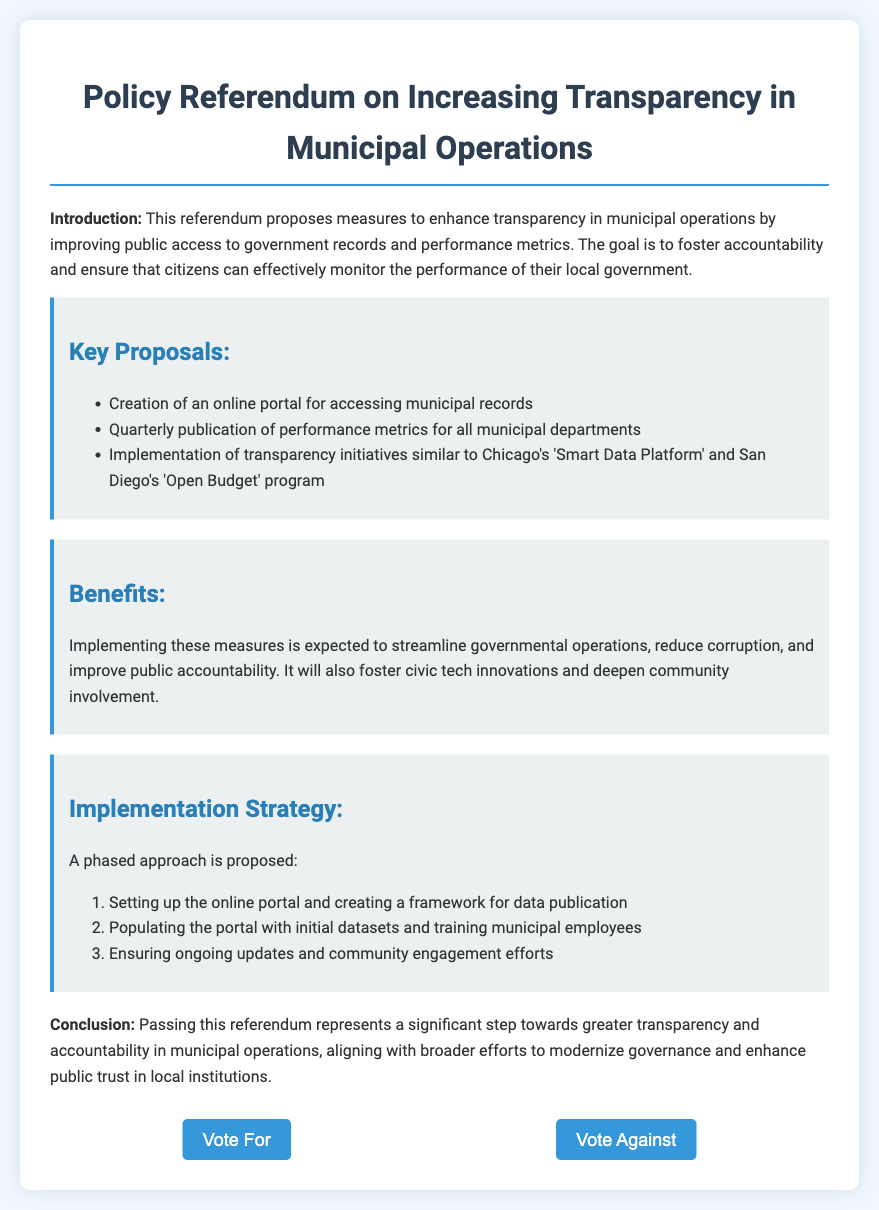What is the title of the referendum? The title of the referendum is mentioned at the top of the document, emphasizing the focus on transparency.
Answer: Policy Referendum on Increasing Transparency in Municipal Operations What is one of the proposed key measures? The key proposals section lists several measures to enhance transparency, with one being particularly highlighted.
Answer: Creation of an online portal for accessing municipal records What is the expected benefit of implementing these measures? The benefits section provides insight into the outcomes anticipated from the proposals, mentioning a specific impact on governance.
Answer: Improve public accountability What is the implementation strategy's first step? The implementation strategy outlines a phased approach, including a specific first step for launching the initiative.
Answer: Setting up the online portal and creating a framework for data publication How many proposals are listed in the document? The key proposals section enumerates the various initiatives, which are clearly stated in a list format.
Answer: Three What initiative is compared to Chicago's 'Smart Data Platform'? The document mentions initiatives that reflect on existing programs aimed at increasing transparency, including a specific example from another city.
Answer: San Diego's 'Open Budget' program What type of document is this? The structural elements and specific formatting suggest the purpose of the document, which relates to public voting.
Answer: Ballot What phase involves community engagement? The implementation strategy suggests a focus on engaging the community during a particular phase of execution.
Answer: Ensuring ongoing updates and community engagement efforts 